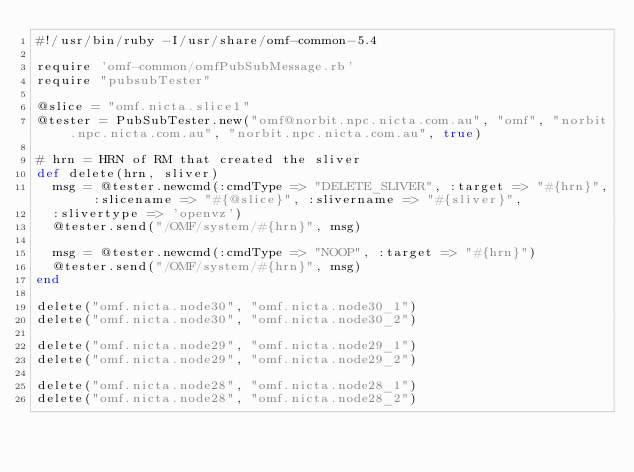<code> <loc_0><loc_0><loc_500><loc_500><_Ruby_>#!/usr/bin/ruby -I/usr/share/omf-common-5.4

require 'omf-common/omfPubSubMessage.rb'
require "pubsubTester"

@slice = "omf.nicta.slice1"
@tester = PubSubTester.new("omf@norbit.npc.nicta.com.au", "omf", "norbit.npc.nicta.com.au", "norbit.npc.nicta.com.au", true)

# hrn = HRN of RM that created the sliver
def delete(hrn, sliver)
  msg = @tester.newcmd(:cmdType => "DELETE_SLIVER", :target => "#{hrn}", :slicename => "#{@slice}", :slivername => "#{sliver}", 
  :slivertype => 'openvz')
  @tester.send("/OMF/system/#{hrn}", msg)

  msg = @tester.newcmd(:cmdType => "NOOP", :target => "#{hrn}")
  @tester.send("/OMF/system/#{hrn}", msg)
end

delete("omf.nicta.node30", "omf.nicta.node30_1")
delete("omf.nicta.node30", "omf.nicta.node30_2")

delete("omf.nicta.node29", "omf.nicta.node29_1")
delete("omf.nicta.node29", "omf.nicta.node29_2")

delete("omf.nicta.node28", "omf.nicta.node28_1")
delete("omf.nicta.node28", "omf.nicta.node28_2")

</code> 